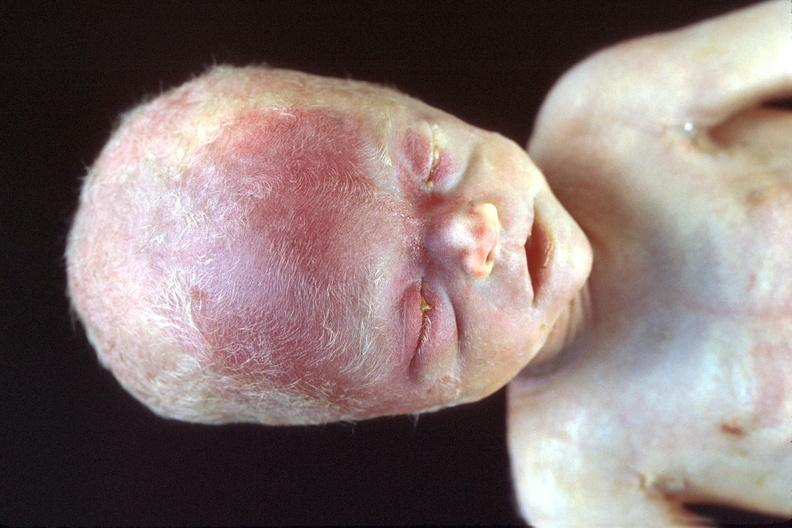does this image show hyaline membrane disease?
Answer the question using a single word or phrase. Yes 